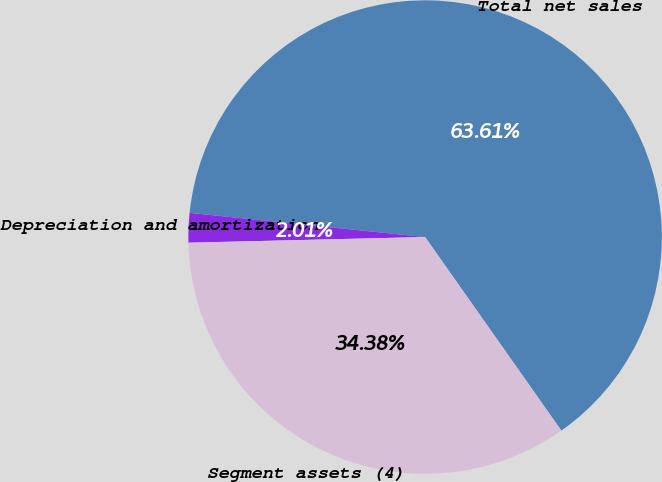<chart> <loc_0><loc_0><loc_500><loc_500><pie_chart><fcel>Total net sales<fcel>Depreciation and amortization<fcel>Segment assets (4)<nl><fcel>63.61%<fcel>2.01%<fcel>34.38%<nl></chart> 